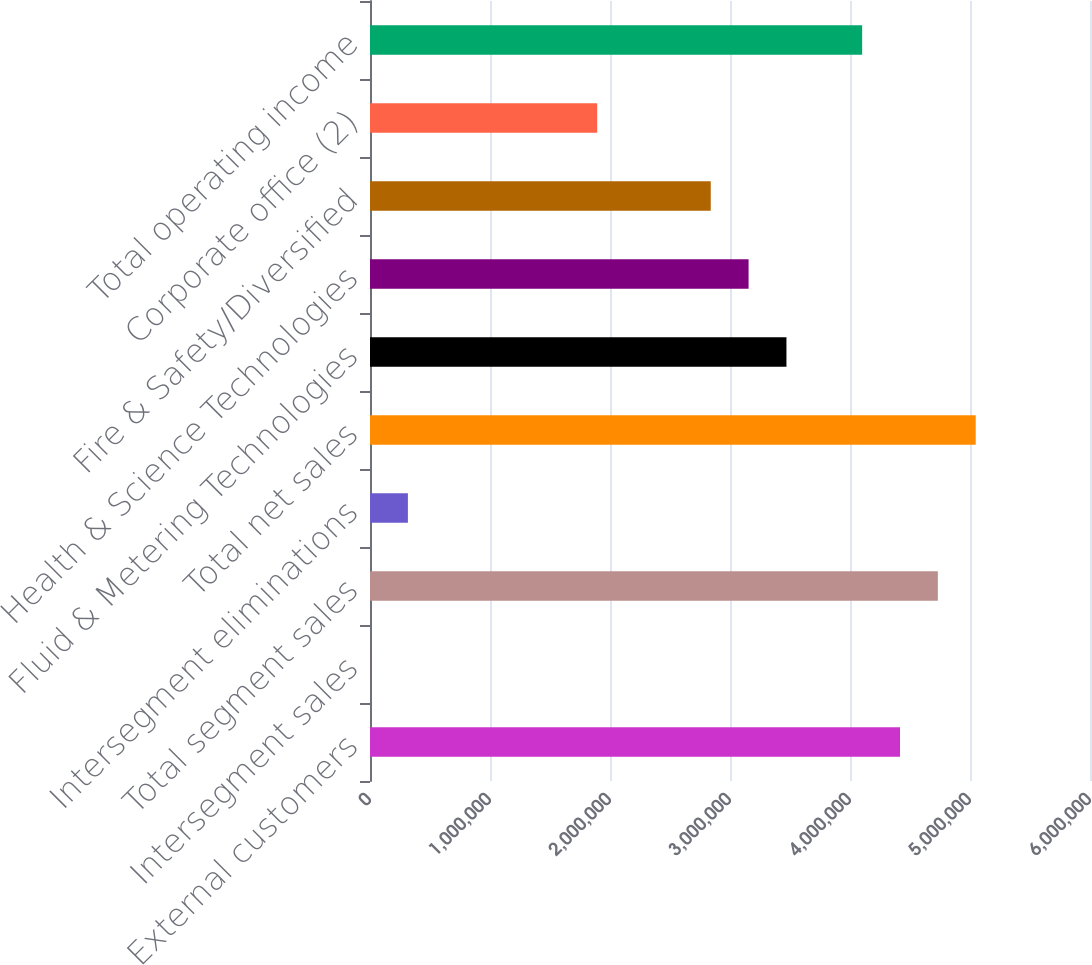Convert chart. <chart><loc_0><loc_0><loc_500><loc_500><bar_chart><fcel>External customers<fcel>Intersegment sales<fcel>Total segment sales<fcel>Intersegment eliminations<fcel>Total net sales<fcel>Fluid & Metering Technologies<fcel>Health & Science Technologies<fcel>Fire & Safety/Diversified<fcel>Corporate office (2)<fcel>Total operating income<nl><fcel>4.41676e+06<fcel>393<fcel>4.73222e+06<fcel>315848<fcel>5.04767e+06<fcel>3.4704e+06<fcel>3.15494e+06<fcel>2.83949e+06<fcel>1.89312e+06<fcel>4.10131e+06<nl></chart> 